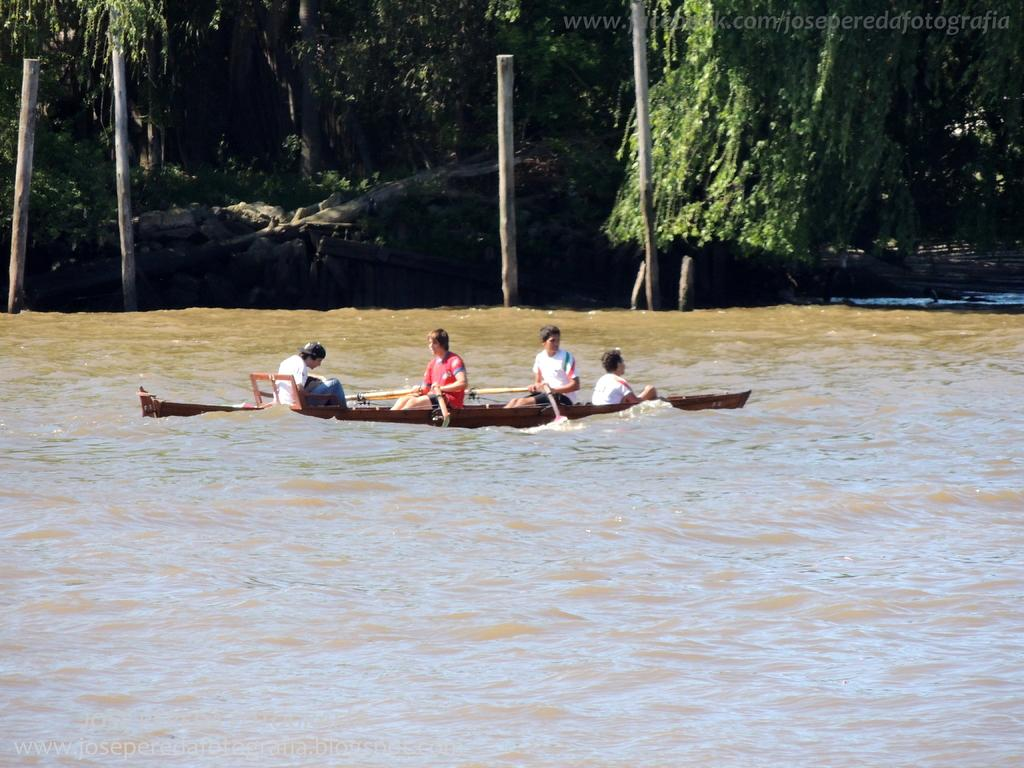What is the primary element in the image? There is water in the image. What is floating on the water? There is a boat in the image. Who or what is present in the boat? There are people in the image. What else can be seen in the water? There are wooden logs in the image. What is visible in the background of the image? There are trees in the image. Is there any additional information or marking on the image? There is a watermark in the image. What type of poison is being used by the people in the image? There is no poison present in the image; it features a boat on water with people and wooden logs. Can you smell the receipt in the image? There is no receipt present in the image, so it cannot be smelled. 